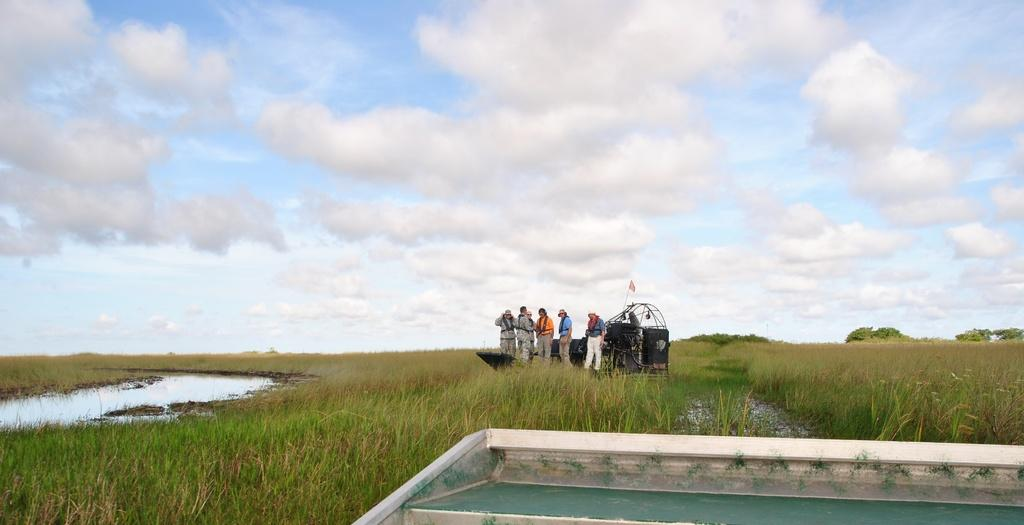How many people are in the image? There are persons in the image, but the exact number is not specified. What is on the ground in the image? There is an object on the ground in the image. What color is the ground? The ground is green. What can be seen in the left corner of the image? There is water in the left corner of the image. What is the condition of the sky in the image? The sky is cloudy. What type of alarm is ringing in the image? There is no alarm present in the image. What direction is the wind blowing in the image? There is no mention of wind in the image. What kind of jewel can be seen on the person's neck in the image? There is no person wearing a jewel in the image. 